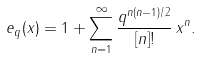Convert formula to latex. <formula><loc_0><loc_0><loc_500><loc_500>e _ { q } ( x ) = 1 + \sum _ { n = 1 } ^ { \infty } \frac { q ^ { n ( n - 1 ) / 2 } } { [ n ] ! } \, x ^ { n } .</formula> 